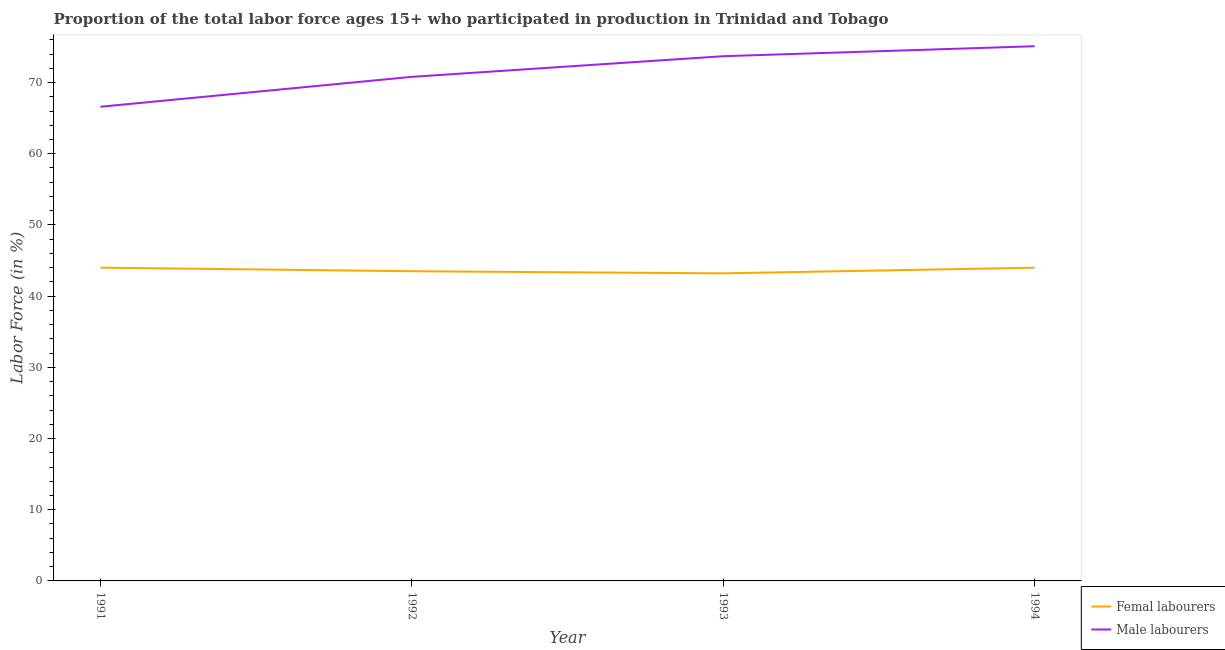Does the line corresponding to percentage of male labour force intersect with the line corresponding to percentage of female labor force?
Provide a succinct answer. No. Across all years, what is the maximum percentage of female labor force?
Provide a short and direct response. 44. Across all years, what is the minimum percentage of male labour force?
Ensure brevity in your answer.  66.6. In which year was the percentage of female labor force maximum?
Provide a short and direct response. 1991. In which year was the percentage of male labour force minimum?
Give a very brief answer. 1991. What is the total percentage of female labor force in the graph?
Give a very brief answer. 174.7. What is the difference between the percentage of male labour force in 1991 and that in 1992?
Provide a succinct answer. -4.2. What is the difference between the percentage of male labour force in 1991 and the percentage of female labor force in 1993?
Provide a succinct answer. 23.4. What is the average percentage of female labor force per year?
Your answer should be compact. 43.68. In the year 1994, what is the difference between the percentage of male labour force and percentage of female labor force?
Ensure brevity in your answer.  31.1. In how many years, is the percentage of male labour force greater than 44 %?
Offer a very short reply. 4. What is the ratio of the percentage of female labor force in 1993 to that in 1994?
Provide a succinct answer. 0.98. What is the difference between the highest and the lowest percentage of female labor force?
Your answer should be compact. 0.8. In how many years, is the percentage of male labour force greater than the average percentage of male labour force taken over all years?
Provide a succinct answer. 2. Is the percentage of male labour force strictly greater than the percentage of female labor force over the years?
Ensure brevity in your answer.  Yes. How many years are there in the graph?
Provide a short and direct response. 4. What is the difference between two consecutive major ticks on the Y-axis?
Give a very brief answer. 10. Are the values on the major ticks of Y-axis written in scientific E-notation?
Keep it short and to the point. No. Does the graph contain any zero values?
Your answer should be compact. No. How are the legend labels stacked?
Provide a succinct answer. Vertical. What is the title of the graph?
Make the answer very short. Proportion of the total labor force ages 15+ who participated in production in Trinidad and Tobago. What is the label or title of the X-axis?
Your answer should be compact. Year. What is the Labor Force (in %) of Male labourers in 1991?
Make the answer very short. 66.6. What is the Labor Force (in %) in Femal labourers in 1992?
Offer a very short reply. 43.5. What is the Labor Force (in %) of Male labourers in 1992?
Your response must be concise. 70.8. What is the Labor Force (in %) of Femal labourers in 1993?
Provide a succinct answer. 43.2. What is the Labor Force (in %) of Male labourers in 1993?
Your answer should be compact. 73.7. What is the Labor Force (in %) in Femal labourers in 1994?
Offer a very short reply. 44. What is the Labor Force (in %) of Male labourers in 1994?
Your answer should be compact. 75.1. Across all years, what is the maximum Labor Force (in %) of Male labourers?
Your answer should be compact. 75.1. Across all years, what is the minimum Labor Force (in %) of Femal labourers?
Ensure brevity in your answer.  43.2. Across all years, what is the minimum Labor Force (in %) of Male labourers?
Ensure brevity in your answer.  66.6. What is the total Labor Force (in %) of Femal labourers in the graph?
Offer a terse response. 174.7. What is the total Labor Force (in %) in Male labourers in the graph?
Keep it short and to the point. 286.2. What is the difference between the Labor Force (in %) of Femal labourers in 1991 and that in 1992?
Your answer should be compact. 0.5. What is the difference between the Labor Force (in %) of Femal labourers in 1991 and that in 1993?
Provide a succinct answer. 0.8. What is the difference between the Labor Force (in %) in Femal labourers in 1992 and that in 1993?
Offer a terse response. 0.3. What is the difference between the Labor Force (in %) of Femal labourers in 1992 and that in 1994?
Keep it short and to the point. -0.5. What is the difference between the Labor Force (in %) in Male labourers in 1992 and that in 1994?
Offer a terse response. -4.3. What is the difference between the Labor Force (in %) in Femal labourers in 1993 and that in 1994?
Ensure brevity in your answer.  -0.8. What is the difference between the Labor Force (in %) of Femal labourers in 1991 and the Labor Force (in %) of Male labourers in 1992?
Make the answer very short. -26.8. What is the difference between the Labor Force (in %) of Femal labourers in 1991 and the Labor Force (in %) of Male labourers in 1993?
Make the answer very short. -29.7. What is the difference between the Labor Force (in %) in Femal labourers in 1991 and the Labor Force (in %) in Male labourers in 1994?
Your response must be concise. -31.1. What is the difference between the Labor Force (in %) in Femal labourers in 1992 and the Labor Force (in %) in Male labourers in 1993?
Ensure brevity in your answer.  -30.2. What is the difference between the Labor Force (in %) in Femal labourers in 1992 and the Labor Force (in %) in Male labourers in 1994?
Provide a short and direct response. -31.6. What is the difference between the Labor Force (in %) in Femal labourers in 1993 and the Labor Force (in %) in Male labourers in 1994?
Provide a succinct answer. -31.9. What is the average Labor Force (in %) in Femal labourers per year?
Provide a short and direct response. 43.67. What is the average Labor Force (in %) of Male labourers per year?
Make the answer very short. 71.55. In the year 1991, what is the difference between the Labor Force (in %) in Femal labourers and Labor Force (in %) in Male labourers?
Offer a very short reply. -22.6. In the year 1992, what is the difference between the Labor Force (in %) of Femal labourers and Labor Force (in %) of Male labourers?
Provide a succinct answer. -27.3. In the year 1993, what is the difference between the Labor Force (in %) in Femal labourers and Labor Force (in %) in Male labourers?
Give a very brief answer. -30.5. In the year 1994, what is the difference between the Labor Force (in %) in Femal labourers and Labor Force (in %) in Male labourers?
Offer a terse response. -31.1. What is the ratio of the Labor Force (in %) in Femal labourers in 1991 to that in 1992?
Offer a terse response. 1.01. What is the ratio of the Labor Force (in %) in Male labourers in 1991 to that in 1992?
Ensure brevity in your answer.  0.94. What is the ratio of the Labor Force (in %) in Femal labourers in 1991 to that in 1993?
Keep it short and to the point. 1.02. What is the ratio of the Labor Force (in %) in Male labourers in 1991 to that in 1993?
Ensure brevity in your answer.  0.9. What is the ratio of the Labor Force (in %) of Femal labourers in 1991 to that in 1994?
Provide a short and direct response. 1. What is the ratio of the Labor Force (in %) of Male labourers in 1991 to that in 1994?
Ensure brevity in your answer.  0.89. What is the ratio of the Labor Force (in %) of Femal labourers in 1992 to that in 1993?
Your answer should be very brief. 1.01. What is the ratio of the Labor Force (in %) of Male labourers in 1992 to that in 1993?
Ensure brevity in your answer.  0.96. What is the ratio of the Labor Force (in %) in Male labourers in 1992 to that in 1994?
Keep it short and to the point. 0.94. What is the ratio of the Labor Force (in %) in Femal labourers in 1993 to that in 1994?
Your answer should be compact. 0.98. What is the ratio of the Labor Force (in %) in Male labourers in 1993 to that in 1994?
Keep it short and to the point. 0.98. What is the difference between the highest and the lowest Labor Force (in %) of Femal labourers?
Make the answer very short. 0.8. What is the difference between the highest and the lowest Labor Force (in %) in Male labourers?
Provide a succinct answer. 8.5. 